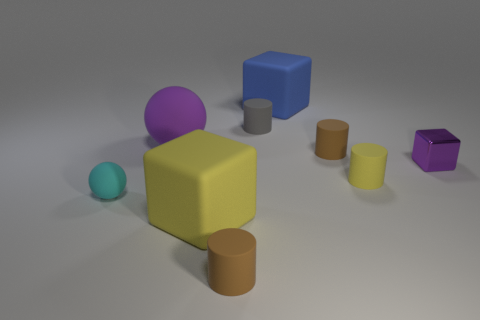Is the tiny shiny block the same color as the big rubber ball?
Your response must be concise. Yes. What is the size of the block in front of the metallic cube that is right of the brown cylinder behind the cyan thing?
Keep it short and to the point. Large. How many other objects are there of the same size as the cyan matte sphere?
Offer a very short reply. 5. How many small cyan spheres have the same material as the purple sphere?
Provide a succinct answer. 1. There is a small brown object in front of the small purple thing; what shape is it?
Make the answer very short. Cylinder. Are the big sphere and the large block in front of the purple shiny cube made of the same material?
Provide a succinct answer. Yes. Are any brown shiny balls visible?
Ensure brevity in your answer.  No. Is there a matte cube that is to the right of the small matte thing in front of the small matte object to the left of the large yellow rubber thing?
Offer a very short reply. Yes. What number of big things are purple spheres or cyan rubber spheres?
Offer a terse response. 1. The block that is the same size as the cyan ball is what color?
Keep it short and to the point. Purple. 